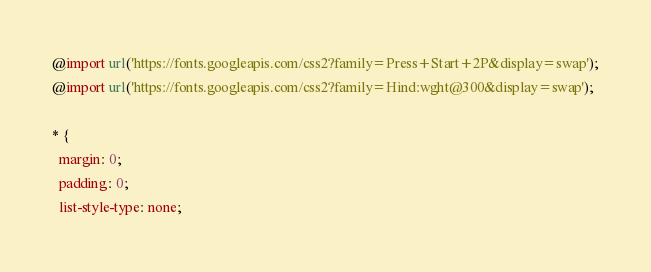Convert code to text. <code><loc_0><loc_0><loc_500><loc_500><_CSS_>@import url('https://fonts.googleapis.com/css2?family=Press+Start+2P&display=swap');
@import url('https://fonts.googleapis.com/css2?family=Hind:wght@300&display=swap');

* {
  margin: 0;
  padding: 0;
  list-style-type: none;</code> 